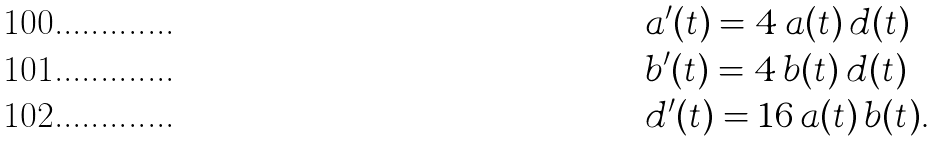<formula> <loc_0><loc_0><loc_500><loc_500>& a ^ { \prime } ( t ) = 4 \, a ( t ) \, d ( t ) \\ & b ^ { \prime } ( t ) = 4 \, b ( t ) \, d ( t ) \\ & d ^ { \prime } ( t ) = 1 6 \, a ( t ) \, b ( t ) .</formula> 